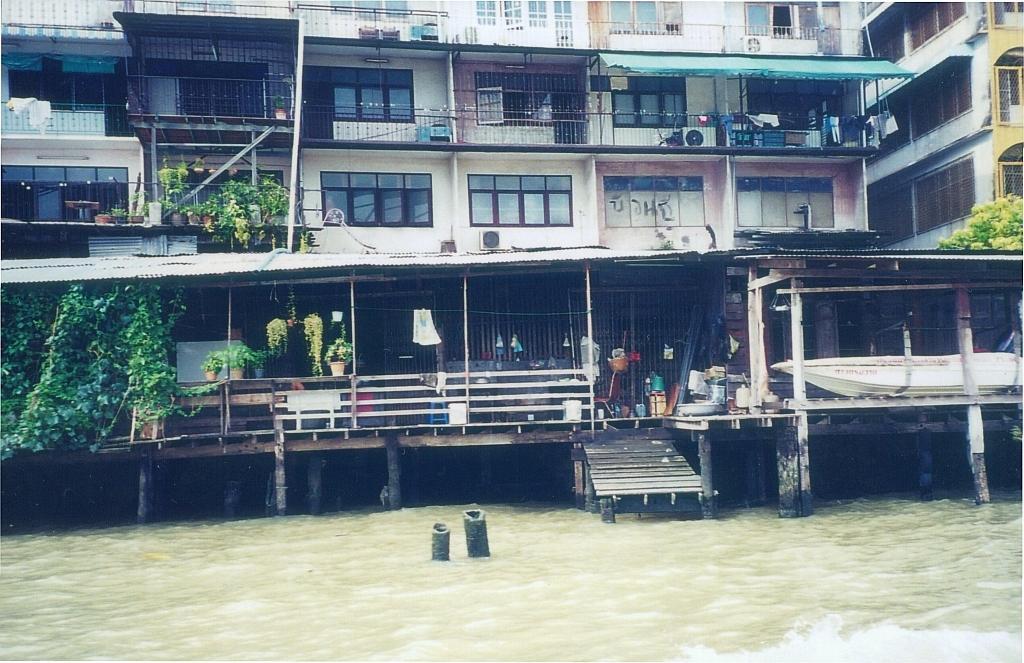Please provide a concise description of this image. In this image I can see buildings, plants, flower pots, fence and a boat on the building. Here I can see water. Here I can also see windows, clothes and some other objects on the building. 